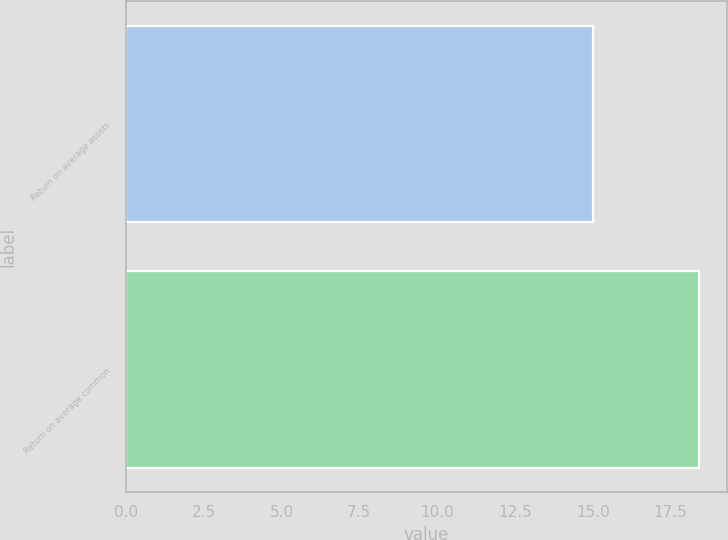Convert chart to OTSL. <chart><loc_0><loc_0><loc_500><loc_500><bar_chart><fcel>Return on average assets<fcel>Return on average common<nl><fcel>15<fcel>18.4<nl></chart> 